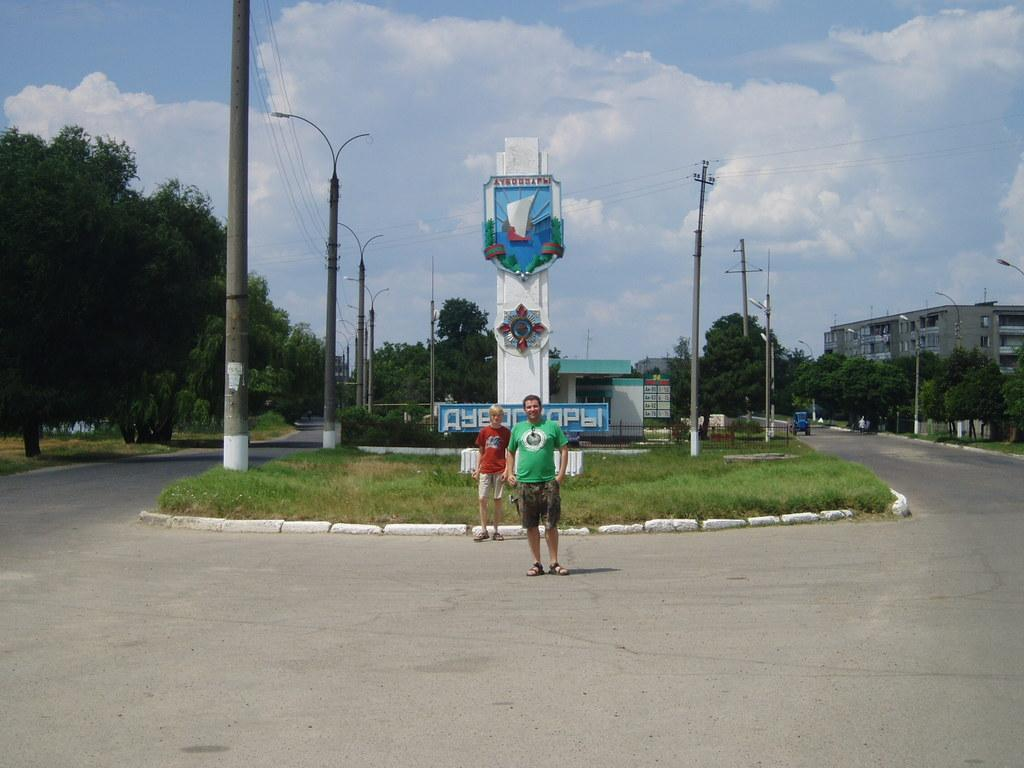What is the weather like in the image? The sky is cloudy in the image. What type of structures can be seen in the image? There are buildings with windows in the image. What type of vegetation is present in the image? Trees and grass are present in the image. What type of utility poles are visible in the image? A current pole and light poles are present in the image. What type of enclosure is present in the image? There is a fence in the image. Are there any people visible in the image? Yes, people are visible in the image. What type of education is being provided to the goose in the image? There is no goose present in the image, so no education can be observed. Who is the representative of the people in the image? There is no specific representative mentioned or depicted in the image. 